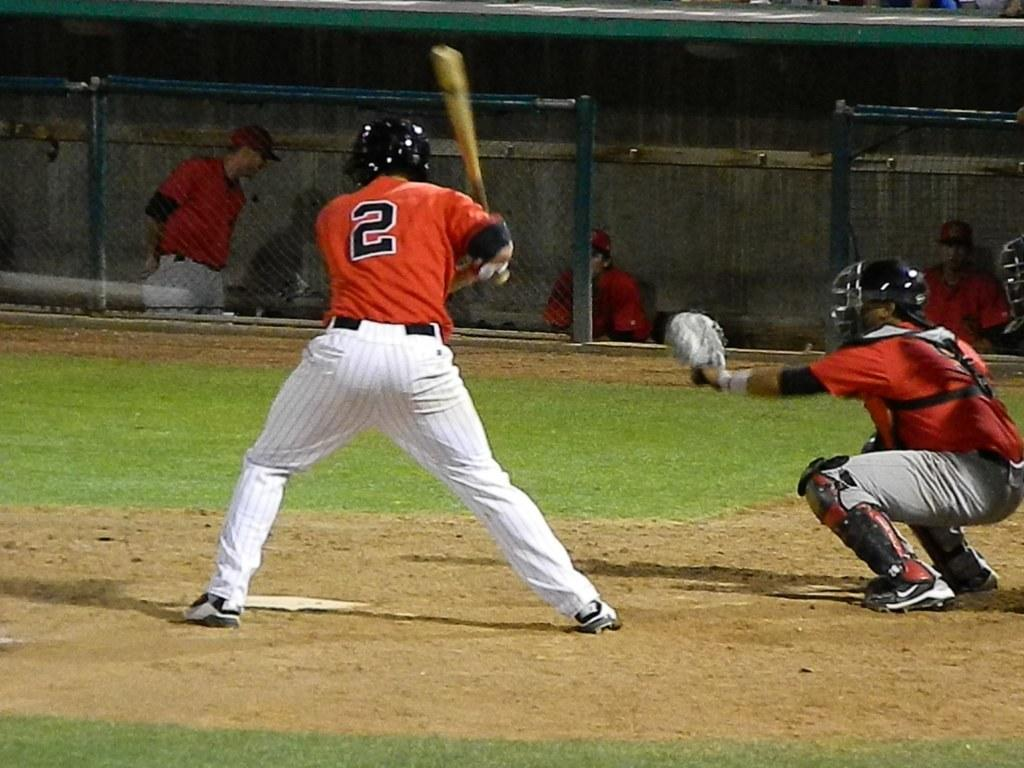<image>
Describe the image concisely. baseball game with number two up to bat. 